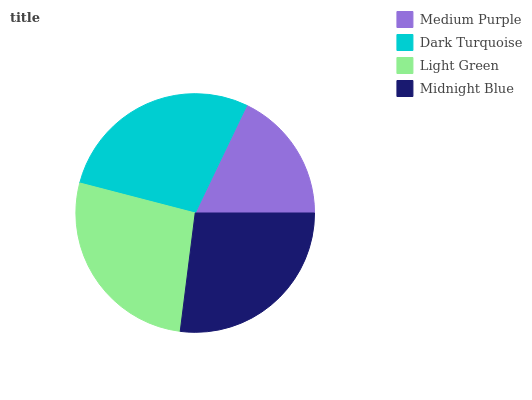Is Medium Purple the minimum?
Answer yes or no. Yes. Is Dark Turquoise the maximum?
Answer yes or no. Yes. Is Light Green the minimum?
Answer yes or no. No. Is Light Green the maximum?
Answer yes or no. No. Is Dark Turquoise greater than Light Green?
Answer yes or no. Yes. Is Light Green less than Dark Turquoise?
Answer yes or no. Yes. Is Light Green greater than Dark Turquoise?
Answer yes or no. No. Is Dark Turquoise less than Light Green?
Answer yes or no. No. Is Light Green the high median?
Answer yes or no. Yes. Is Midnight Blue the low median?
Answer yes or no. Yes. Is Midnight Blue the high median?
Answer yes or no. No. Is Medium Purple the low median?
Answer yes or no. No. 